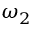<formula> <loc_0><loc_0><loc_500><loc_500>\omega _ { 2 }</formula> 